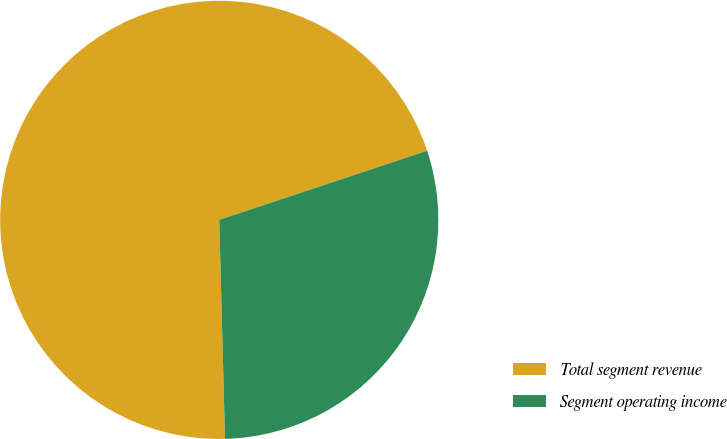Convert chart. <chart><loc_0><loc_0><loc_500><loc_500><pie_chart><fcel>Total segment revenue<fcel>Segment operating income<nl><fcel>70.31%<fcel>29.69%<nl></chart> 